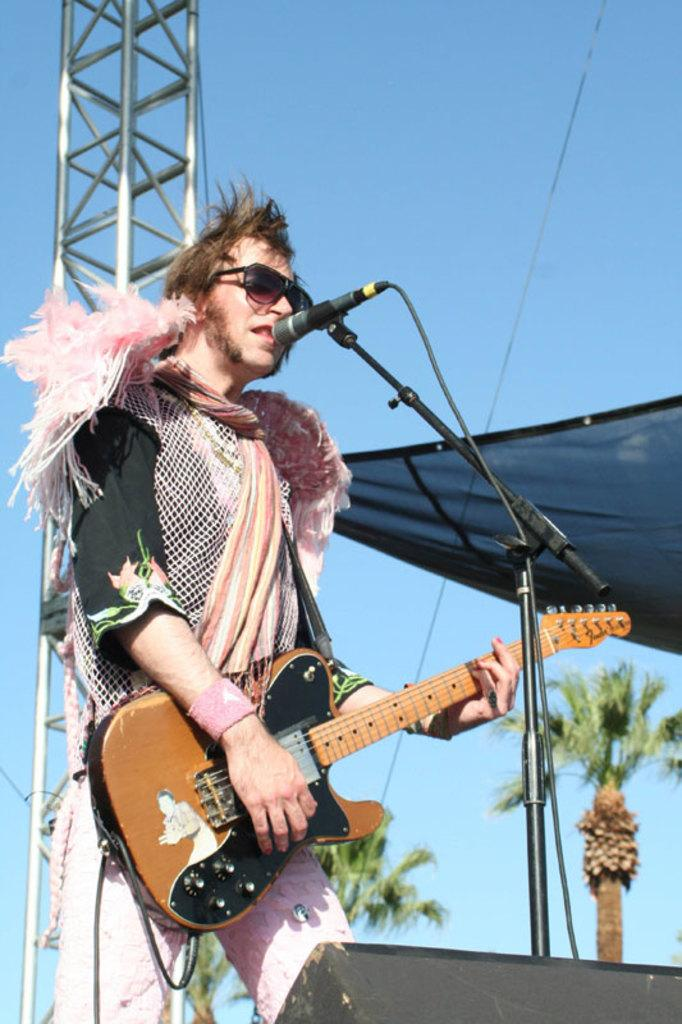What is the person in the image doing? The person is singing on a mic and playing a guitar. What can be seen behind the person? There is a pole behind the person, and cloth and the sky are visible in the background. What else is present in the background? Trees are present in the background. How many fangs can be seen on the person playing the guitar in the image? There are no fangs visible on the person playing the guitar in the image. What fact is being presented in the image? The image does not present any specific fact; it shows a person singing and playing the guitar. 